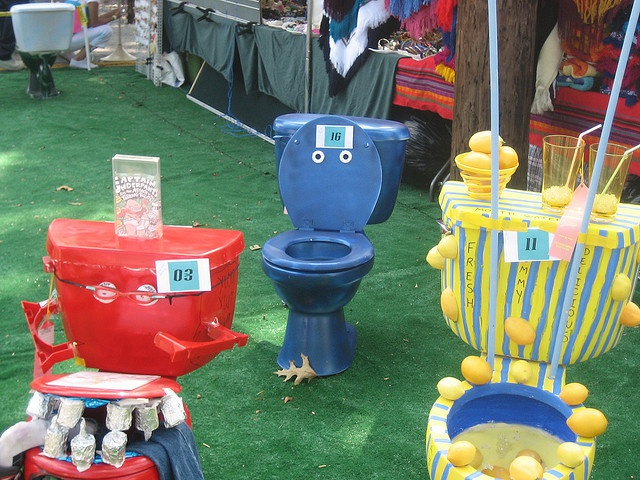Describe the objects in this image and their specific colors. I can see toilet in black, khaki, beige, and gray tones, toilet in black, brown, and salmon tones, toilet in black, gray, blue, and darkblue tones, and toilet in black, gray, and darkgray tones in this image. 